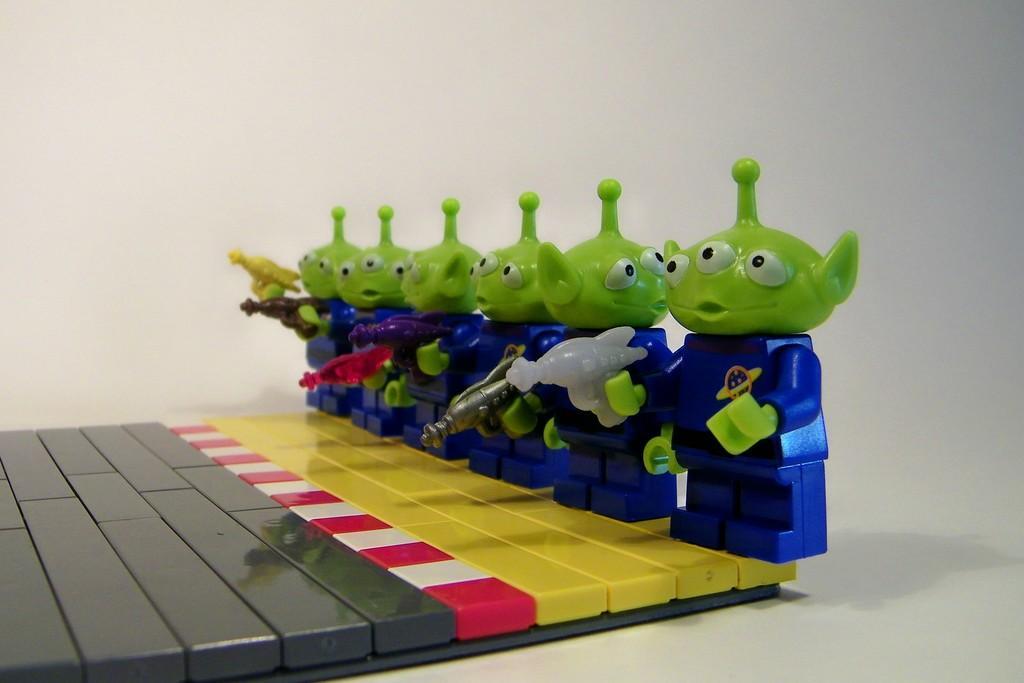In one or two sentences, can you explain what this image depicts? In this picture there are six plastic toys and holding guns. The toys are standing on the plastic board. In the background there is a wall. 